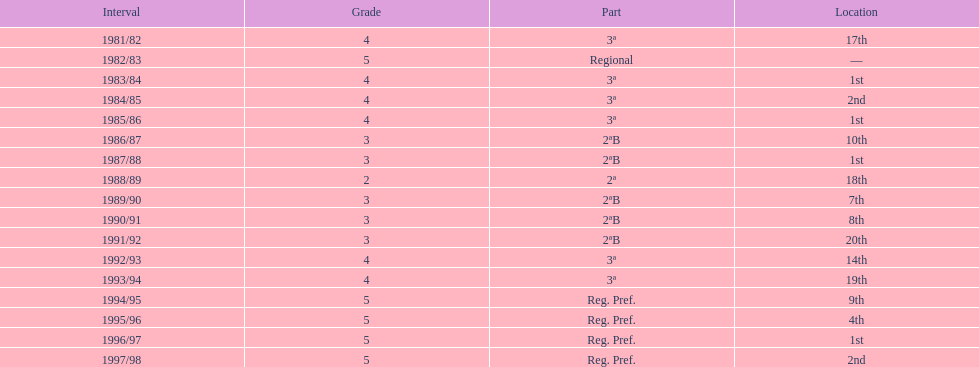How many times was the runner-up position achieved? 2. 